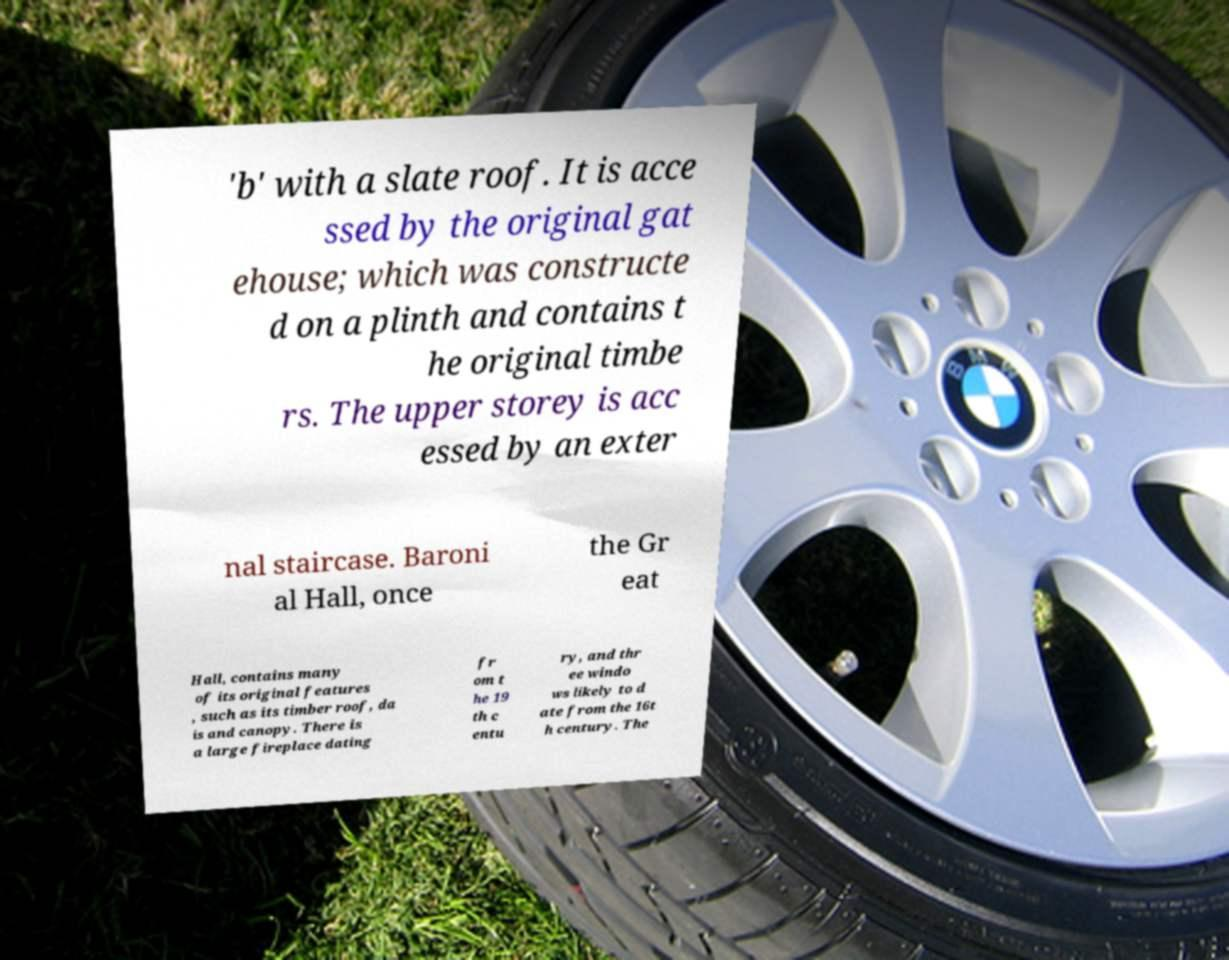Could you extract and type out the text from this image? 'b' with a slate roof. It is acce ssed by the original gat ehouse; which was constructe d on a plinth and contains t he original timbe rs. The upper storey is acc essed by an exter nal staircase. Baroni al Hall, once the Gr eat Hall, contains many of its original features , such as its timber roof, da is and canopy. There is a large fireplace dating fr om t he 19 th c entu ry, and thr ee windo ws likely to d ate from the 16t h century. The 